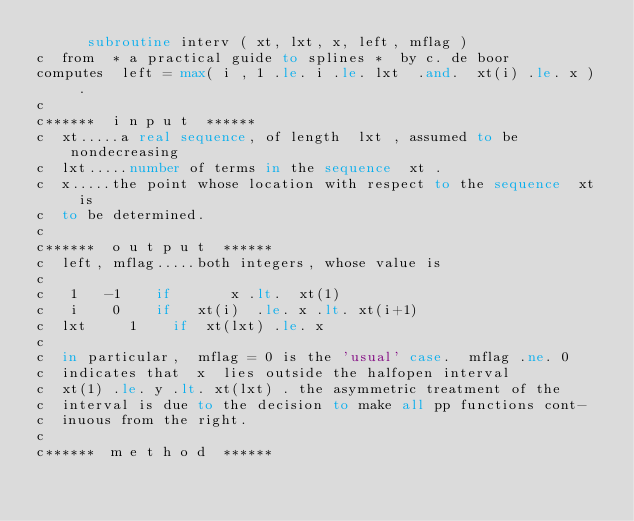Convert code to text. <code><loc_0><loc_0><loc_500><loc_500><_FORTRAN_>      subroutine interv ( xt, lxt, x, left, mflag )
c  from  * a practical guide to splines *  by c. de boor
computes  left = max( i , 1 .le. i .le. lxt  .and.  xt(i) .le. x )  .
c
c******  i n p u t  ******
c  xt.....a real sequence, of length  lxt , assumed to be nondecreasing
c  lxt.....number of terms in the sequence  xt .
c  x.....the point whose location with respect to the sequence	xt  is
c	 to be determined.
c
c******  o u t p u t  ******
c  left, mflag.....both integers, whose value is
c
c   1	  -1	  if		   x .lt.  xt(1)
c   i	   0	  if   xt(i)  .le. x .lt. xt(i+1)
c  lxt	   1	  if  xt(lxt) .le. x
c
c	 in particular,  mflag = 0 is the 'usual' case.  mflag .ne. 0
c	 indicates that  x  lies outside the halfopen interval
c	 xt(1) .le. y .lt. xt(lxt) . the asymmetric treatment of the
c	 interval is due to the decision to make all pp functions cont-
c	 inuous from the right.
c
c******  m e t h o d  ******</code> 